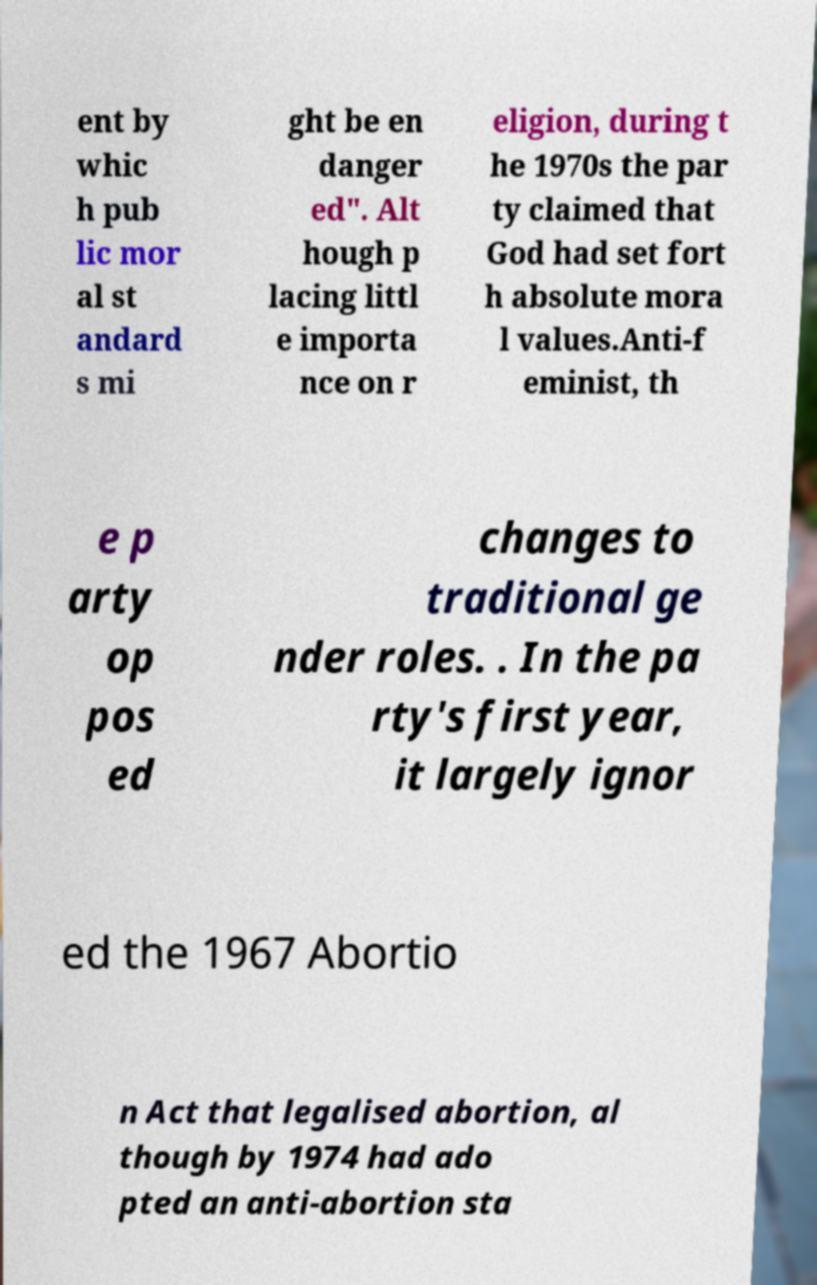Could you assist in decoding the text presented in this image and type it out clearly? ent by whic h pub lic mor al st andard s mi ght be en danger ed". Alt hough p lacing littl e importa nce on r eligion, during t he 1970s the par ty claimed that God had set fort h absolute mora l values.Anti-f eminist, th e p arty op pos ed changes to traditional ge nder roles. . In the pa rty's first year, it largely ignor ed the 1967 Abortio n Act that legalised abortion, al though by 1974 had ado pted an anti-abortion sta 